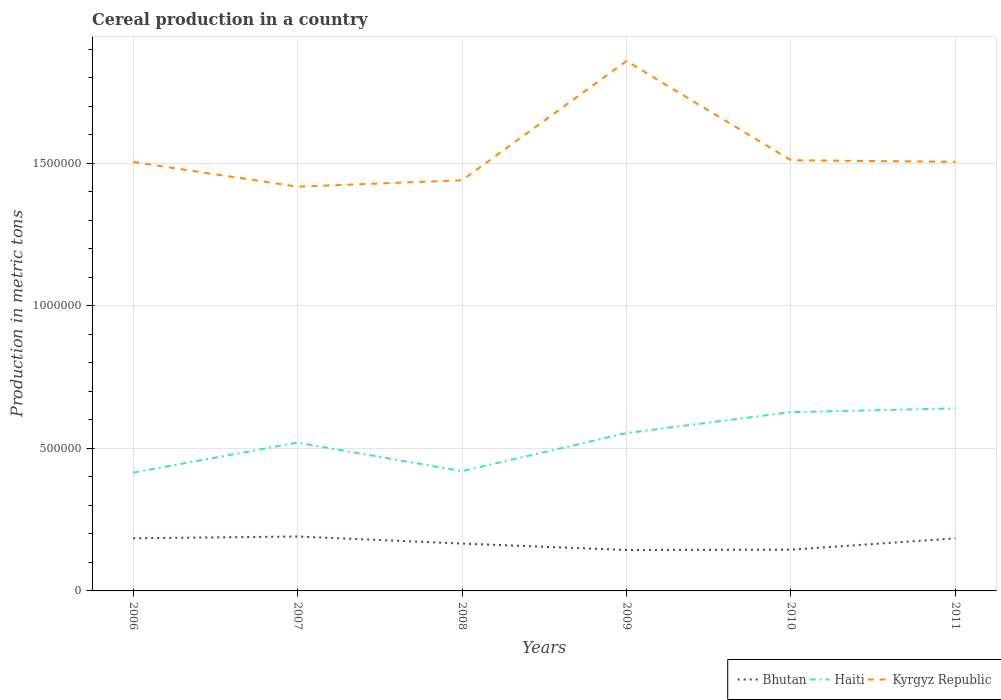How many different coloured lines are there?
Your answer should be compact. 3. Is the number of lines equal to the number of legend labels?
Make the answer very short. Yes. Across all years, what is the maximum total cereal production in Haiti?
Make the answer very short. 4.15e+05. What is the total total cereal production in Kyrgyz Republic in the graph?
Provide a succinct answer. -6266. What is the difference between the highest and the second highest total cereal production in Kyrgyz Republic?
Provide a succinct answer. 4.41e+05. What is the difference between the highest and the lowest total cereal production in Kyrgyz Republic?
Offer a terse response. 1. Is the total cereal production in Bhutan strictly greater than the total cereal production in Haiti over the years?
Make the answer very short. Yes. Are the values on the major ticks of Y-axis written in scientific E-notation?
Your answer should be compact. No. Does the graph contain grids?
Your answer should be very brief. Yes. Where does the legend appear in the graph?
Your answer should be very brief. Bottom right. What is the title of the graph?
Make the answer very short. Cereal production in a country. Does "Papua New Guinea" appear as one of the legend labels in the graph?
Offer a terse response. No. What is the label or title of the X-axis?
Your answer should be compact. Years. What is the label or title of the Y-axis?
Give a very brief answer. Production in metric tons. What is the Production in metric tons of Bhutan in 2006?
Make the answer very short. 1.85e+05. What is the Production in metric tons of Haiti in 2006?
Ensure brevity in your answer.  4.15e+05. What is the Production in metric tons in Kyrgyz Republic in 2006?
Provide a succinct answer. 1.50e+06. What is the Production in metric tons in Bhutan in 2007?
Make the answer very short. 1.91e+05. What is the Production in metric tons of Haiti in 2007?
Your response must be concise. 5.20e+05. What is the Production in metric tons in Kyrgyz Republic in 2007?
Offer a very short reply. 1.42e+06. What is the Production in metric tons of Bhutan in 2008?
Keep it short and to the point. 1.66e+05. What is the Production in metric tons of Haiti in 2008?
Keep it short and to the point. 4.20e+05. What is the Production in metric tons in Kyrgyz Republic in 2008?
Give a very brief answer. 1.44e+06. What is the Production in metric tons in Bhutan in 2009?
Ensure brevity in your answer.  1.44e+05. What is the Production in metric tons in Haiti in 2009?
Keep it short and to the point. 5.54e+05. What is the Production in metric tons of Kyrgyz Republic in 2009?
Your answer should be compact. 1.86e+06. What is the Production in metric tons in Bhutan in 2010?
Provide a succinct answer. 1.45e+05. What is the Production in metric tons of Haiti in 2010?
Ensure brevity in your answer.  6.27e+05. What is the Production in metric tons of Kyrgyz Republic in 2010?
Provide a short and direct response. 1.51e+06. What is the Production in metric tons of Bhutan in 2011?
Provide a short and direct response. 1.84e+05. What is the Production in metric tons in Haiti in 2011?
Make the answer very short. 6.40e+05. What is the Production in metric tons in Kyrgyz Republic in 2011?
Offer a very short reply. 1.50e+06. Across all years, what is the maximum Production in metric tons in Bhutan?
Offer a terse response. 1.91e+05. Across all years, what is the maximum Production in metric tons in Haiti?
Make the answer very short. 6.40e+05. Across all years, what is the maximum Production in metric tons of Kyrgyz Republic?
Provide a succinct answer. 1.86e+06. Across all years, what is the minimum Production in metric tons of Bhutan?
Provide a succinct answer. 1.44e+05. Across all years, what is the minimum Production in metric tons of Haiti?
Offer a terse response. 4.15e+05. Across all years, what is the minimum Production in metric tons of Kyrgyz Republic?
Your answer should be very brief. 1.42e+06. What is the total Production in metric tons of Bhutan in the graph?
Keep it short and to the point. 1.01e+06. What is the total Production in metric tons of Haiti in the graph?
Your answer should be compact. 3.18e+06. What is the total Production in metric tons of Kyrgyz Republic in the graph?
Provide a short and direct response. 9.23e+06. What is the difference between the Production in metric tons of Bhutan in 2006 and that in 2007?
Provide a short and direct response. -6200. What is the difference between the Production in metric tons of Haiti in 2006 and that in 2007?
Give a very brief answer. -1.05e+05. What is the difference between the Production in metric tons in Kyrgyz Republic in 2006 and that in 2007?
Ensure brevity in your answer.  8.64e+04. What is the difference between the Production in metric tons in Bhutan in 2006 and that in 2008?
Your response must be concise. 1.86e+04. What is the difference between the Production in metric tons of Haiti in 2006 and that in 2008?
Your answer should be compact. -5000. What is the difference between the Production in metric tons of Kyrgyz Republic in 2006 and that in 2008?
Your response must be concise. 6.39e+04. What is the difference between the Production in metric tons of Bhutan in 2006 and that in 2009?
Your response must be concise. 4.11e+04. What is the difference between the Production in metric tons in Haiti in 2006 and that in 2009?
Your response must be concise. -1.38e+05. What is the difference between the Production in metric tons of Kyrgyz Republic in 2006 and that in 2009?
Offer a very short reply. -3.54e+05. What is the difference between the Production in metric tons in Bhutan in 2006 and that in 2010?
Your answer should be very brief. 4.00e+04. What is the difference between the Production in metric tons in Haiti in 2006 and that in 2010?
Give a very brief answer. -2.12e+05. What is the difference between the Production in metric tons of Kyrgyz Republic in 2006 and that in 2010?
Make the answer very short. -6266. What is the difference between the Production in metric tons in Bhutan in 2006 and that in 2011?
Your response must be concise. 320. What is the difference between the Production in metric tons in Haiti in 2006 and that in 2011?
Offer a terse response. -2.25e+05. What is the difference between the Production in metric tons in Kyrgyz Republic in 2006 and that in 2011?
Provide a short and direct response. -681. What is the difference between the Production in metric tons of Bhutan in 2007 and that in 2008?
Your answer should be very brief. 2.48e+04. What is the difference between the Production in metric tons of Kyrgyz Republic in 2007 and that in 2008?
Your answer should be very brief. -2.26e+04. What is the difference between the Production in metric tons of Bhutan in 2007 and that in 2009?
Ensure brevity in your answer.  4.73e+04. What is the difference between the Production in metric tons of Haiti in 2007 and that in 2009?
Give a very brief answer. -3.35e+04. What is the difference between the Production in metric tons in Kyrgyz Republic in 2007 and that in 2009?
Offer a terse response. -4.41e+05. What is the difference between the Production in metric tons of Bhutan in 2007 and that in 2010?
Give a very brief answer. 4.62e+04. What is the difference between the Production in metric tons of Haiti in 2007 and that in 2010?
Give a very brief answer. -1.07e+05. What is the difference between the Production in metric tons of Kyrgyz Republic in 2007 and that in 2010?
Your response must be concise. -9.27e+04. What is the difference between the Production in metric tons in Bhutan in 2007 and that in 2011?
Your answer should be compact. 6520. What is the difference between the Production in metric tons of Haiti in 2007 and that in 2011?
Ensure brevity in your answer.  -1.20e+05. What is the difference between the Production in metric tons of Kyrgyz Republic in 2007 and that in 2011?
Offer a very short reply. -8.71e+04. What is the difference between the Production in metric tons of Bhutan in 2008 and that in 2009?
Your answer should be compact. 2.25e+04. What is the difference between the Production in metric tons of Haiti in 2008 and that in 2009?
Your answer should be compact. -1.34e+05. What is the difference between the Production in metric tons of Kyrgyz Republic in 2008 and that in 2009?
Provide a succinct answer. -4.18e+05. What is the difference between the Production in metric tons of Bhutan in 2008 and that in 2010?
Provide a short and direct response. 2.14e+04. What is the difference between the Production in metric tons in Haiti in 2008 and that in 2010?
Offer a terse response. -2.07e+05. What is the difference between the Production in metric tons of Kyrgyz Republic in 2008 and that in 2010?
Offer a terse response. -7.01e+04. What is the difference between the Production in metric tons in Bhutan in 2008 and that in 2011?
Make the answer very short. -1.83e+04. What is the difference between the Production in metric tons of Haiti in 2008 and that in 2011?
Keep it short and to the point. -2.20e+05. What is the difference between the Production in metric tons in Kyrgyz Republic in 2008 and that in 2011?
Keep it short and to the point. -6.45e+04. What is the difference between the Production in metric tons in Bhutan in 2009 and that in 2010?
Give a very brief answer. -1082. What is the difference between the Production in metric tons in Haiti in 2009 and that in 2010?
Keep it short and to the point. -7.34e+04. What is the difference between the Production in metric tons of Kyrgyz Republic in 2009 and that in 2010?
Provide a short and direct response. 3.48e+05. What is the difference between the Production in metric tons of Bhutan in 2009 and that in 2011?
Offer a terse response. -4.08e+04. What is the difference between the Production in metric tons in Haiti in 2009 and that in 2011?
Your answer should be very brief. -8.66e+04. What is the difference between the Production in metric tons of Kyrgyz Republic in 2009 and that in 2011?
Make the answer very short. 3.53e+05. What is the difference between the Production in metric tons of Bhutan in 2010 and that in 2011?
Ensure brevity in your answer.  -3.97e+04. What is the difference between the Production in metric tons of Haiti in 2010 and that in 2011?
Provide a succinct answer. -1.32e+04. What is the difference between the Production in metric tons of Kyrgyz Republic in 2010 and that in 2011?
Make the answer very short. 5585. What is the difference between the Production in metric tons of Bhutan in 2006 and the Production in metric tons of Haiti in 2007?
Your response must be concise. -3.35e+05. What is the difference between the Production in metric tons of Bhutan in 2006 and the Production in metric tons of Kyrgyz Republic in 2007?
Your answer should be compact. -1.23e+06. What is the difference between the Production in metric tons of Haiti in 2006 and the Production in metric tons of Kyrgyz Republic in 2007?
Provide a short and direct response. -1.00e+06. What is the difference between the Production in metric tons of Bhutan in 2006 and the Production in metric tons of Haiti in 2008?
Make the answer very short. -2.35e+05. What is the difference between the Production in metric tons of Bhutan in 2006 and the Production in metric tons of Kyrgyz Republic in 2008?
Your answer should be compact. -1.26e+06. What is the difference between the Production in metric tons in Haiti in 2006 and the Production in metric tons in Kyrgyz Republic in 2008?
Provide a short and direct response. -1.03e+06. What is the difference between the Production in metric tons in Bhutan in 2006 and the Production in metric tons in Haiti in 2009?
Keep it short and to the point. -3.69e+05. What is the difference between the Production in metric tons in Bhutan in 2006 and the Production in metric tons in Kyrgyz Republic in 2009?
Your answer should be compact. -1.67e+06. What is the difference between the Production in metric tons of Haiti in 2006 and the Production in metric tons of Kyrgyz Republic in 2009?
Keep it short and to the point. -1.44e+06. What is the difference between the Production in metric tons in Bhutan in 2006 and the Production in metric tons in Haiti in 2010?
Offer a terse response. -4.42e+05. What is the difference between the Production in metric tons in Bhutan in 2006 and the Production in metric tons in Kyrgyz Republic in 2010?
Give a very brief answer. -1.33e+06. What is the difference between the Production in metric tons in Haiti in 2006 and the Production in metric tons in Kyrgyz Republic in 2010?
Offer a very short reply. -1.10e+06. What is the difference between the Production in metric tons of Bhutan in 2006 and the Production in metric tons of Haiti in 2011?
Your response must be concise. -4.55e+05. What is the difference between the Production in metric tons of Bhutan in 2006 and the Production in metric tons of Kyrgyz Republic in 2011?
Offer a terse response. -1.32e+06. What is the difference between the Production in metric tons of Haiti in 2006 and the Production in metric tons of Kyrgyz Republic in 2011?
Your response must be concise. -1.09e+06. What is the difference between the Production in metric tons of Bhutan in 2007 and the Production in metric tons of Haiti in 2008?
Your answer should be very brief. -2.29e+05. What is the difference between the Production in metric tons of Bhutan in 2007 and the Production in metric tons of Kyrgyz Republic in 2008?
Offer a terse response. -1.25e+06. What is the difference between the Production in metric tons in Haiti in 2007 and the Production in metric tons in Kyrgyz Republic in 2008?
Keep it short and to the point. -9.20e+05. What is the difference between the Production in metric tons in Bhutan in 2007 and the Production in metric tons in Haiti in 2009?
Ensure brevity in your answer.  -3.63e+05. What is the difference between the Production in metric tons in Bhutan in 2007 and the Production in metric tons in Kyrgyz Republic in 2009?
Keep it short and to the point. -1.67e+06. What is the difference between the Production in metric tons in Haiti in 2007 and the Production in metric tons in Kyrgyz Republic in 2009?
Keep it short and to the point. -1.34e+06. What is the difference between the Production in metric tons in Bhutan in 2007 and the Production in metric tons in Haiti in 2010?
Your response must be concise. -4.36e+05. What is the difference between the Production in metric tons of Bhutan in 2007 and the Production in metric tons of Kyrgyz Republic in 2010?
Ensure brevity in your answer.  -1.32e+06. What is the difference between the Production in metric tons in Haiti in 2007 and the Production in metric tons in Kyrgyz Republic in 2010?
Give a very brief answer. -9.90e+05. What is the difference between the Production in metric tons of Bhutan in 2007 and the Production in metric tons of Haiti in 2011?
Your answer should be compact. -4.49e+05. What is the difference between the Production in metric tons of Bhutan in 2007 and the Production in metric tons of Kyrgyz Republic in 2011?
Offer a terse response. -1.31e+06. What is the difference between the Production in metric tons in Haiti in 2007 and the Production in metric tons in Kyrgyz Republic in 2011?
Offer a terse response. -9.85e+05. What is the difference between the Production in metric tons in Bhutan in 2008 and the Production in metric tons in Haiti in 2009?
Your response must be concise. -3.87e+05. What is the difference between the Production in metric tons in Bhutan in 2008 and the Production in metric tons in Kyrgyz Republic in 2009?
Make the answer very short. -1.69e+06. What is the difference between the Production in metric tons in Haiti in 2008 and the Production in metric tons in Kyrgyz Republic in 2009?
Your response must be concise. -1.44e+06. What is the difference between the Production in metric tons of Bhutan in 2008 and the Production in metric tons of Haiti in 2010?
Give a very brief answer. -4.61e+05. What is the difference between the Production in metric tons of Bhutan in 2008 and the Production in metric tons of Kyrgyz Republic in 2010?
Keep it short and to the point. -1.34e+06. What is the difference between the Production in metric tons of Haiti in 2008 and the Production in metric tons of Kyrgyz Republic in 2010?
Your answer should be compact. -1.09e+06. What is the difference between the Production in metric tons of Bhutan in 2008 and the Production in metric tons of Haiti in 2011?
Offer a very short reply. -4.74e+05. What is the difference between the Production in metric tons in Bhutan in 2008 and the Production in metric tons in Kyrgyz Republic in 2011?
Offer a terse response. -1.34e+06. What is the difference between the Production in metric tons of Haiti in 2008 and the Production in metric tons of Kyrgyz Republic in 2011?
Ensure brevity in your answer.  -1.08e+06. What is the difference between the Production in metric tons in Bhutan in 2009 and the Production in metric tons in Haiti in 2010?
Ensure brevity in your answer.  -4.83e+05. What is the difference between the Production in metric tons in Bhutan in 2009 and the Production in metric tons in Kyrgyz Republic in 2010?
Provide a short and direct response. -1.37e+06. What is the difference between the Production in metric tons in Haiti in 2009 and the Production in metric tons in Kyrgyz Republic in 2010?
Provide a short and direct response. -9.57e+05. What is the difference between the Production in metric tons of Bhutan in 2009 and the Production in metric tons of Haiti in 2011?
Offer a terse response. -4.97e+05. What is the difference between the Production in metric tons of Bhutan in 2009 and the Production in metric tons of Kyrgyz Republic in 2011?
Your answer should be very brief. -1.36e+06. What is the difference between the Production in metric tons in Haiti in 2009 and the Production in metric tons in Kyrgyz Republic in 2011?
Your response must be concise. -9.51e+05. What is the difference between the Production in metric tons in Bhutan in 2010 and the Production in metric tons in Haiti in 2011?
Your response must be concise. -4.95e+05. What is the difference between the Production in metric tons of Bhutan in 2010 and the Production in metric tons of Kyrgyz Republic in 2011?
Give a very brief answer. -1.36e+06. What is the difference between the Production in metric tons of Haiti in 2010 and the Production in metric tons of Kyrgyz Republic in 2011?
Provide a short and direct response. -8.78e+05. What is the average Production in metric tons of Bhutan per year?
Make the answer very short. 1.69e+05. What is the average Production in metric tons of Haiti per year?
Keep it short and to the point. 5.29e+05. What is the average Production in metric tons of Kyrgyz Republic per year?
Provide a short and direct response. 1.54e+06. In the year 2006, what is the difference between the Production in metric tons of Bhutan and Production in metric tons of Haiti?
Keep it short and to the point. -2.30e+05. In the year 2006, what is the difference between the Production in metric tons of Bhutan and Production in metric tons of Kyrgyz Republic?
Provide a short and direct response. -1.32e+06. In the year 2006, what is the difference between the Production in metric tons in Haiti and Production in metric tons in Kyrgyz Republic?
Your answer should be compact. -1.09e+06. In the year 2007, what is the difference between the Production in metric tons in Bhutan and Production in metric tons in Haiti?
Offer a terse response. -3.29e+05. In the year 2007, what is the difference between the Production in metric tons in Bhutan and Production in metric tons in Kyrgyz Republic?
Give a very brief answer. -1.23e+06. In the year 2007, what is the difference between the Production in metric tons of Haiti and Production in metric tons of Kyrgyz Republic?
Provide a succinct answer. -8.98e+05. In the year 2008, what is the difference between the Production in metric tons in Bhutan and Production in metric tons in Haiti?
Provide a short and direct response. -2.54e+05. In the year 2008, what is the difference between the Production in metric tons of Bhutan and Production in metric tons of Kyrgyz Republic?
Ensure brevity in your answer.  -1.27e+06. In the year 2008, what is the difference between the Production in metric tons of Haiti and Production in metric tons of Kyrgyz Republic?
Give a very brief answer. -1.02e+06. In the year 2009, what is the difference between the Production in metric tons of Bhutan and Production in metric tons of Haiti?
Offer a terse response. -4.10e+05. In the year 2009, what is the difference between the Production in metric tons in Bhutan and Production in metric tons in Kyrgyz Republic?
Provide a short and direct response. -1.71e+06. In the year 2009, what is the difference between the Production in metric tons in Haiti and Production in metric tons in Kyrgyz Republic?
Your answer should be compact. -1.30e+06. In the year 2010, what is the difference between the Production in metric tons in Bhutan and Production in metric tons in Haiti?
Offer a terse response. -4.82e+05. In the year 2010, what is the difference between the Production in metric tons in Bhutan and Production in metric tons in Kyrgyz Republic?
Your answer should be very brief. -1.37e+06. In the year 2010, what is the difference between the Production in metric tons in Haiti and Production in metric tons in Kyrgyz Republic?
Your answer should be compact. -8.83e+05. In the year 2011, what is the difference between the Production in metric tons in Bhutan and Production in metric tons in Haiti?
Ensure brevity in your answer.  -4.56e+05. In the year 2011, what is the difference between the Production in metric tons in Bhutan and Production in metric tons in Kyrgyz Republic?
Your response must be concise. -1.32e+06. In the year 2011, what is the difference between the Production in metric tons in Haiti and Production in metric tons in Kyrgyz Republic?
Your response must be concise. -8.65e+05. What is the ratio of the Production in metric tons in Bhutan in 2006 to that in 2007?
Ensure brevity in your answer.  0.97. What is the ratio of the Production in metric tons in Haiti in 2006 to that in 2007?
Your answer should be compact. 0.8. What is the ratio of the Production in metric tons of Kyrgyz Republic in 2006 to that in 2007?
Ensure brevity in your answer.  1.06. What is the ratio of the Production in metric tons of Bhutan in 2006 to that in 2008?
Provide a short and direct response. 1.11. What is the ratio of the Production in metric tons in Kyrgyz Republic in 2006 to that in 2008?
Give a very brief answer. 1.04. What is the ratio of the Production in metric tons in Bhutan in 2006 to that in 2009?
Provide a short and direct response. 1.29. What is the ratio of the Production in metric tons of Haiti in 2006 to that in 2009?
Offer a very short reply. 0.75. What is the ratio of the Production in metric tons of Kyrgyz Republic in 2006 to that in 2009?
Give a very brief answer. 0.81. What is the ratio of the Production in metric tons of Bhutan in 2006 to that in 2010?
Provide a short and direct response. 1.28. What is the ratio of the Production in metric tons in Haiti in 2006 to that in 2010?
Provide a short and direct response. 0.66. What is the ratio of the Production in metric tons of Bhutan in 2006 to that in 2011?
Keep it short and to the point. 1. What is the ratio of the Production in metric tons of Haiti in 2006 to that in 2011?
Your response must be concise. 0.65. What is the ratio of the Production in metric tons in Kyrgyz Republic in 2006 to that in 2011?
Keep it short and to the point. 1. What is the ratio of the Production in metric tons of Bhutan in 2007 to that in 2008?
Offer a terse response. 1.15. What is the ratio of the Production in metric tons of Haiti in 2007 to that in 2008?
Ensure brevity in your answer.  1.24. What is the ratio of the Production in metric tons of Kyrgyz Republic in 2007 to that in 2008?
Provide a succinct answer. 0.98. What is the ratio of the Production in metric tons in Bhutan in 2007 to that in 2009?
Your answer should be very brief. 1.33. What is the ratio of the Production in metric tons in Haiti in 2007 to that in 2009?
Keep it short and to the point. 0.94. What is the ratio of the Production in metric tons in Kyrgyz Republic in 2007 to that in 2009?
Make the answer very short. 0.76. What is the ratio of the Production in metric tons of Bhutan in 2007 to that in 2010?
Your answer should be compact. 1.32. What is the ratio of the Production in metric tons in Haiti in 2007 to that in 2010?
Provide a short and direct response. 0.83. What is the ratio of the Production in metric tons in Kyrgyz Republic in 2007 to that in 2010?
Ensure brevity in your answer.  0.94. What is the ratio of the Production in metric tons in Bhutan in 2007 to that in 2011?
Your answer should be compact. 1.04. What is the ratio of the Production in metric tons in Haiti in 2007 to that in 2011?
Your answer should be compact. 0.81. What is the ratio of the Production in metric tons of Kyrgyz Republic in 2007 to that in 2011?
Make the answer very short. 0.94. What is the ratio of the Production in metric tons in Bhutan in 2008 to that in 2009?
Provide a short and direct response. 1.16. What is the ratio of the Production in metric tons of Haiti in 2008 to that in 2009?
Offer a terse response. 0.76. What is the ratio of the Production in metric tons in Kyrgyz Republic in 2008 to that in 2009?
Provide a succinct answer. 0.78. What is the ratio of the Production in metric tons in Bhutan in 2008 to that in 2010?
Ensure brevity in your answer.  1.15. What is the ratio of the Production in metric tons of Haiti in 2008 to that in 2010?
Make the answer very short. 0.67. What is the ratio of the Production in metric tons of Kyrgyz Republic in 2008 to that in 2010?
Your answer should be very brief. 0.95. What is the ratio of the Production in metric tons in Bhutan in 2008 to that in 2011?
Offer a very short reply. 0.9. What is the ratio of the Production in metric tons in Haiti in 2008 to that in 2011?
Your answer should be compact. 0.66. What is the ratio of the Production in metric tons in Kyrgyz Republic in 2008 to that in 2011?
Ensure brevity in your answer.  0.96. What is the ratio of the Production in metric tons in Bhutan in 2009 to that in 2010?
Make the answer very short. 0.99. What is the ratio of the Production in metric tons of Haiti in 2009 to that in 2010?
Offer a very short reply. 0.88. What is the ratio of the Production in metric tons of Kyrgyz Republic in 2009 to that in 2010?
Your answer should be compact. 1.23. What is the ratio of the Production in metric tons in Bhutan in 2009 to that in 2011?
Provide a succinct answer. 0.78. What is the ratio of the Production in metric tons in Haiti in 2009 to that in 2011?
Provide a short and direct response. 0.86. What is the ratio of the Production in metric tons in Kyrgyz Republic in 2009 to that in 2011?
Make the answer very short. 1.23. What is the ratio of the Production in metric tons in Bhutan in 2010 to that in 2011?
Make the answer very short. 0.78. What is the ratio of the Production in metric tons in Haiti in 2010 to that in 2011?
Make the answer very short. 0.98. What is the difference between the highest and the second highest Production in metric tons in Bhutan?
Keep it short and to the point. 6200. What is the difference between the highest and the second highest Production in metric tons of Haiti?
Your response must be concise. 1.32e+04. What is the difference between the highest and the second highest Production in metric tons of Kyrgyz Republic?
Ensure brevity in your answer.  3.48e+05. What is the difference between the highest and the lowest Production in metric tons of Bhutan?
Provide a short and direct response. 4.73e+04. What is the difference between the highest and the lowest Production in metric tons of Haiti?
Provide a succinct answer. 2.25e+05. What is the difference between the highest and the lowest Production in metric tons of Kyrgyz Republic?
Your answer should be very brief. 4.41e+05. 